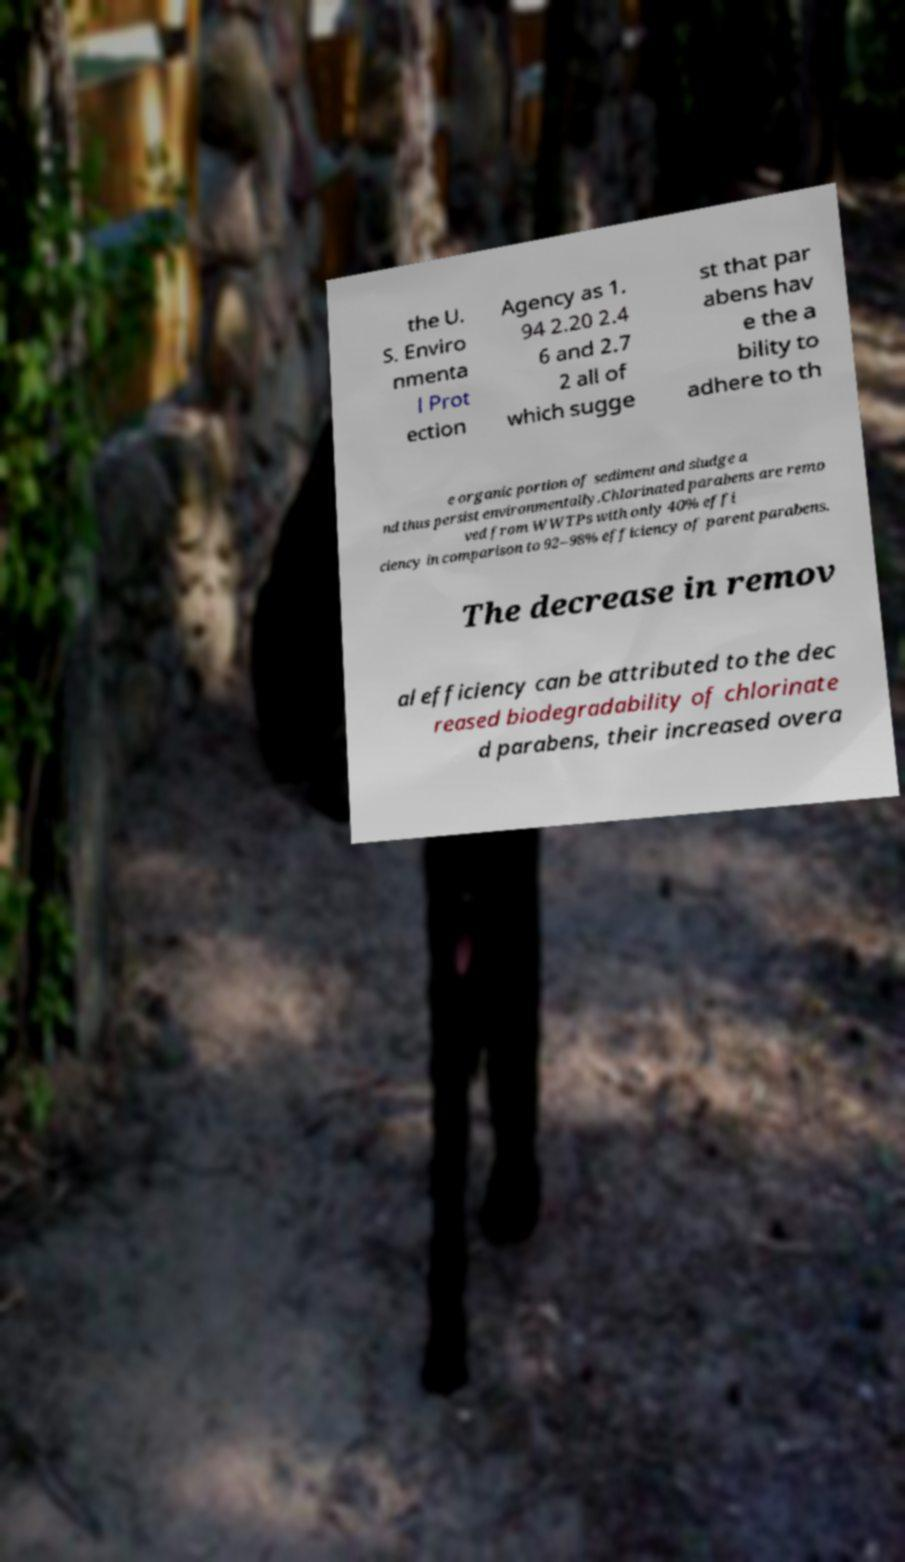I need the written content from this picture converted into text. Can you do that? the U. S. Enviro nmenta l Prot ection Agency as 1. 94 2.20 2.4 6 and 2.7 2 all of which sugge st that par abens hav e the a bility to adhere to th e organic portion of sediment and sludge a nd thus persist environmentally.Chlorinated parabens are remo ved from WWTPs with only 40% effi ciency in comparison to 92–98% efficiency of parent parabens. The decrease in remov al efficiency can be attributed to the dec reased biodegradability of chlorinate d parabens, their increased overa 